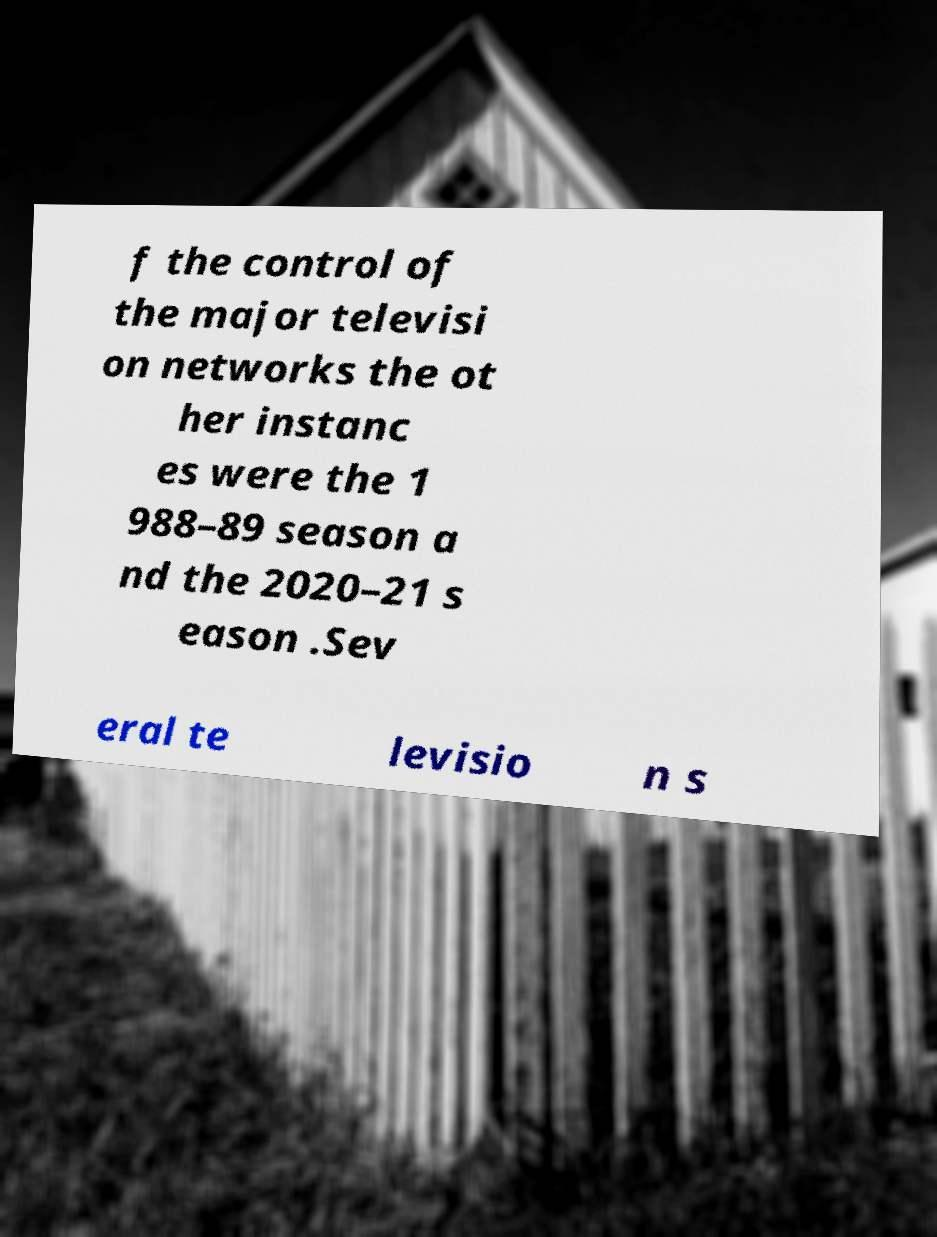What messages or text are displayed in this image? I need them in a readable, typed format. f the control of the major televisi on networks the ot her instanc es were the 1 988–89 season a nd the 2020–21 s eason .Sev eral te levisio n s 